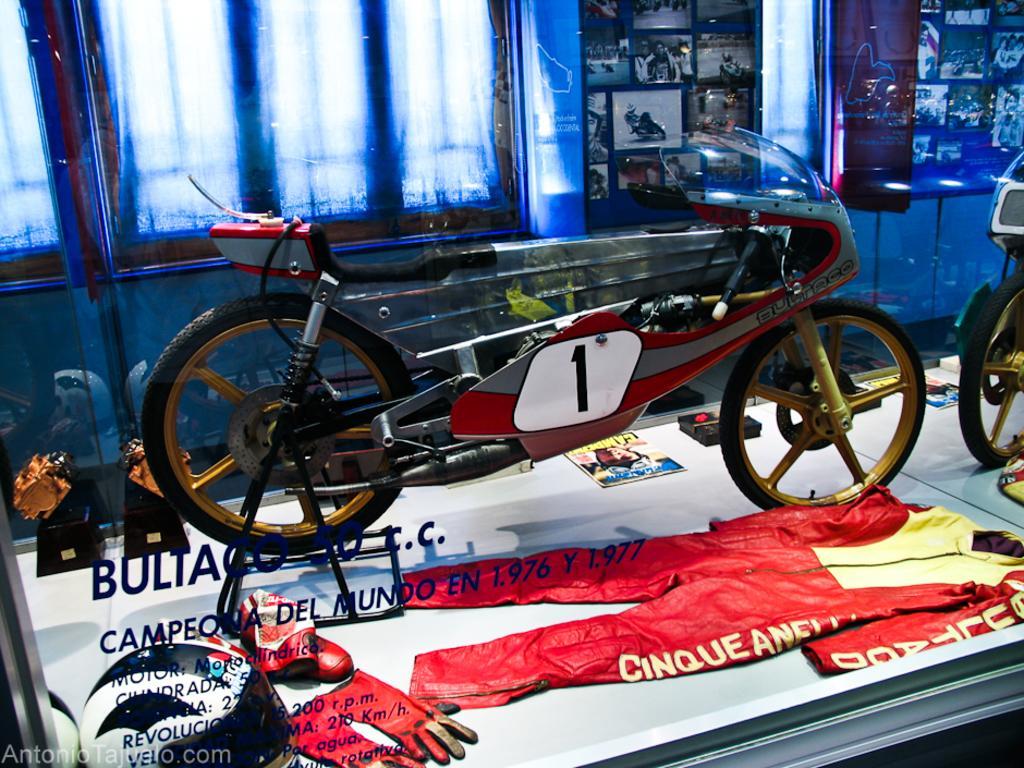Please provide a concise description of this image. In this image we can see two motorcycles, there are clothes, gloves, helmet and some other objects on the floor, there are photographs on the wall, there are text on the mirror, also we can see the windows.  